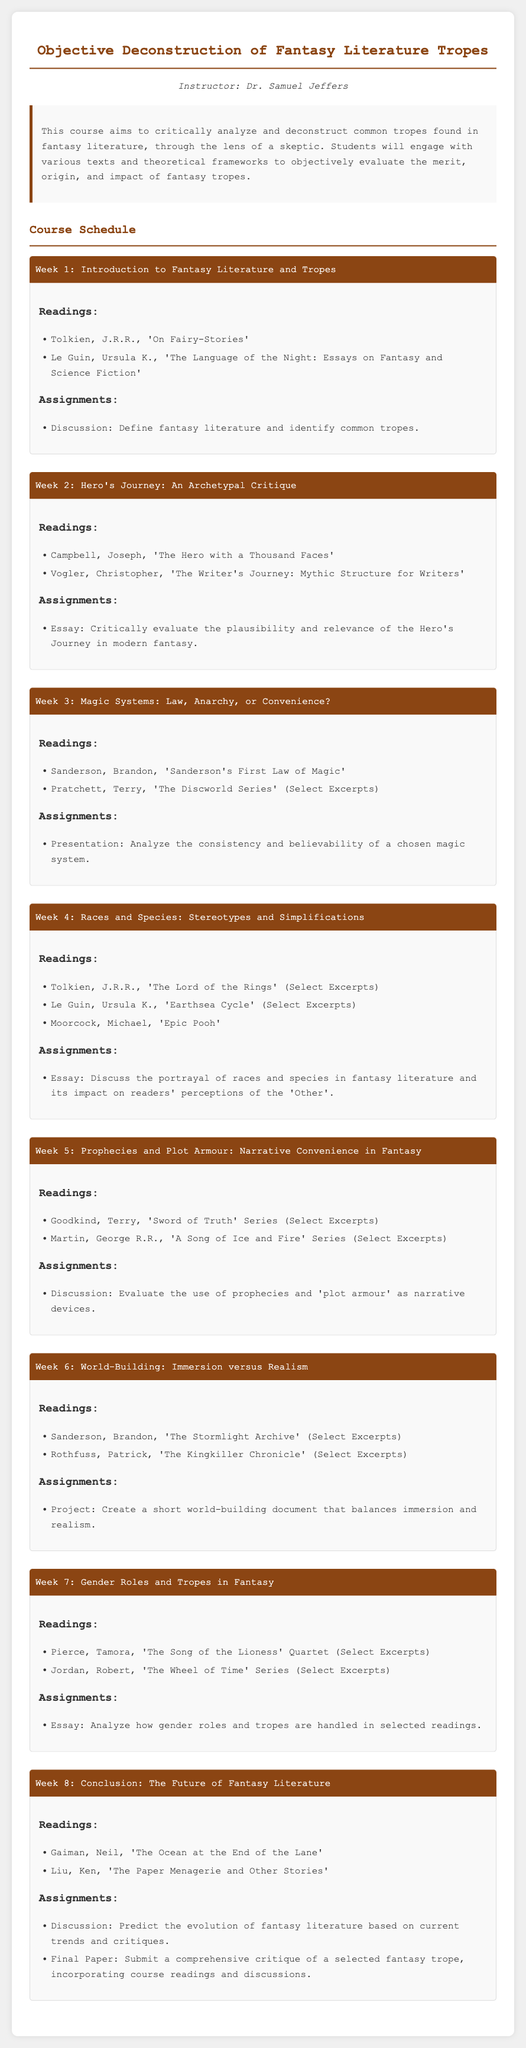What is the course title? The course title is explicitly mentioned at the beginning of the document.
Answer: Objective Deconstruction of Fantasy Literature Tropes Who is the instructor for the course? The instructor's name is given in the syllabus under the instructor section.
Answer: Dr. Samuel Jeffers What are the primary readings for Week 1? The readings for each week are listed in their respective sections, with specific titles and authors.
Answer: Tolkien, J.R.R., 'On Fairy-Stories'; Le Guin, Ursula K., 'The Language of the Night: Essays on Fantasy and Science Fiction' What is the main focus of the Week 4 essay assignment? The essay assignments are found under each week's content, specifying their focuses.
Answer: Discuss the portrayal of races and species in fantasy literature and its impact on readers' perceptions of the 'Other' In which week is the topic of gender roles addressed? The weeks are numbered, and the specific focus of each week is listed.
Answer: Week 7 How many weeks are in the course? The document provides a total count of the weeks in the course schedule.
Answer: Eight Which reading is assigned in the final week? The readings for the last week are identified in the course schedule.
Answer: Gaiman, Neil, 'The Ocean at the End of the Lane'; Liu, Ken, 'The Paper Menagerie and Other Stories' What type of project is assigned in Week 6? The type of assignments for each week varies, specifically noted in the week content.
Answer: Create a short world-building document that balances immersion and realism What is the format of the final assessment? The document states what the final assignment entails.
Answer: Comprehensive critique of a selected fantasy trope 